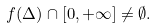Convert formula to latex. <formula><loc_0><loc_0><loc_500><loc_500>f ( \Delta ) \cap [ 0 , + \infty ] \neq \emptyset .</formula> 